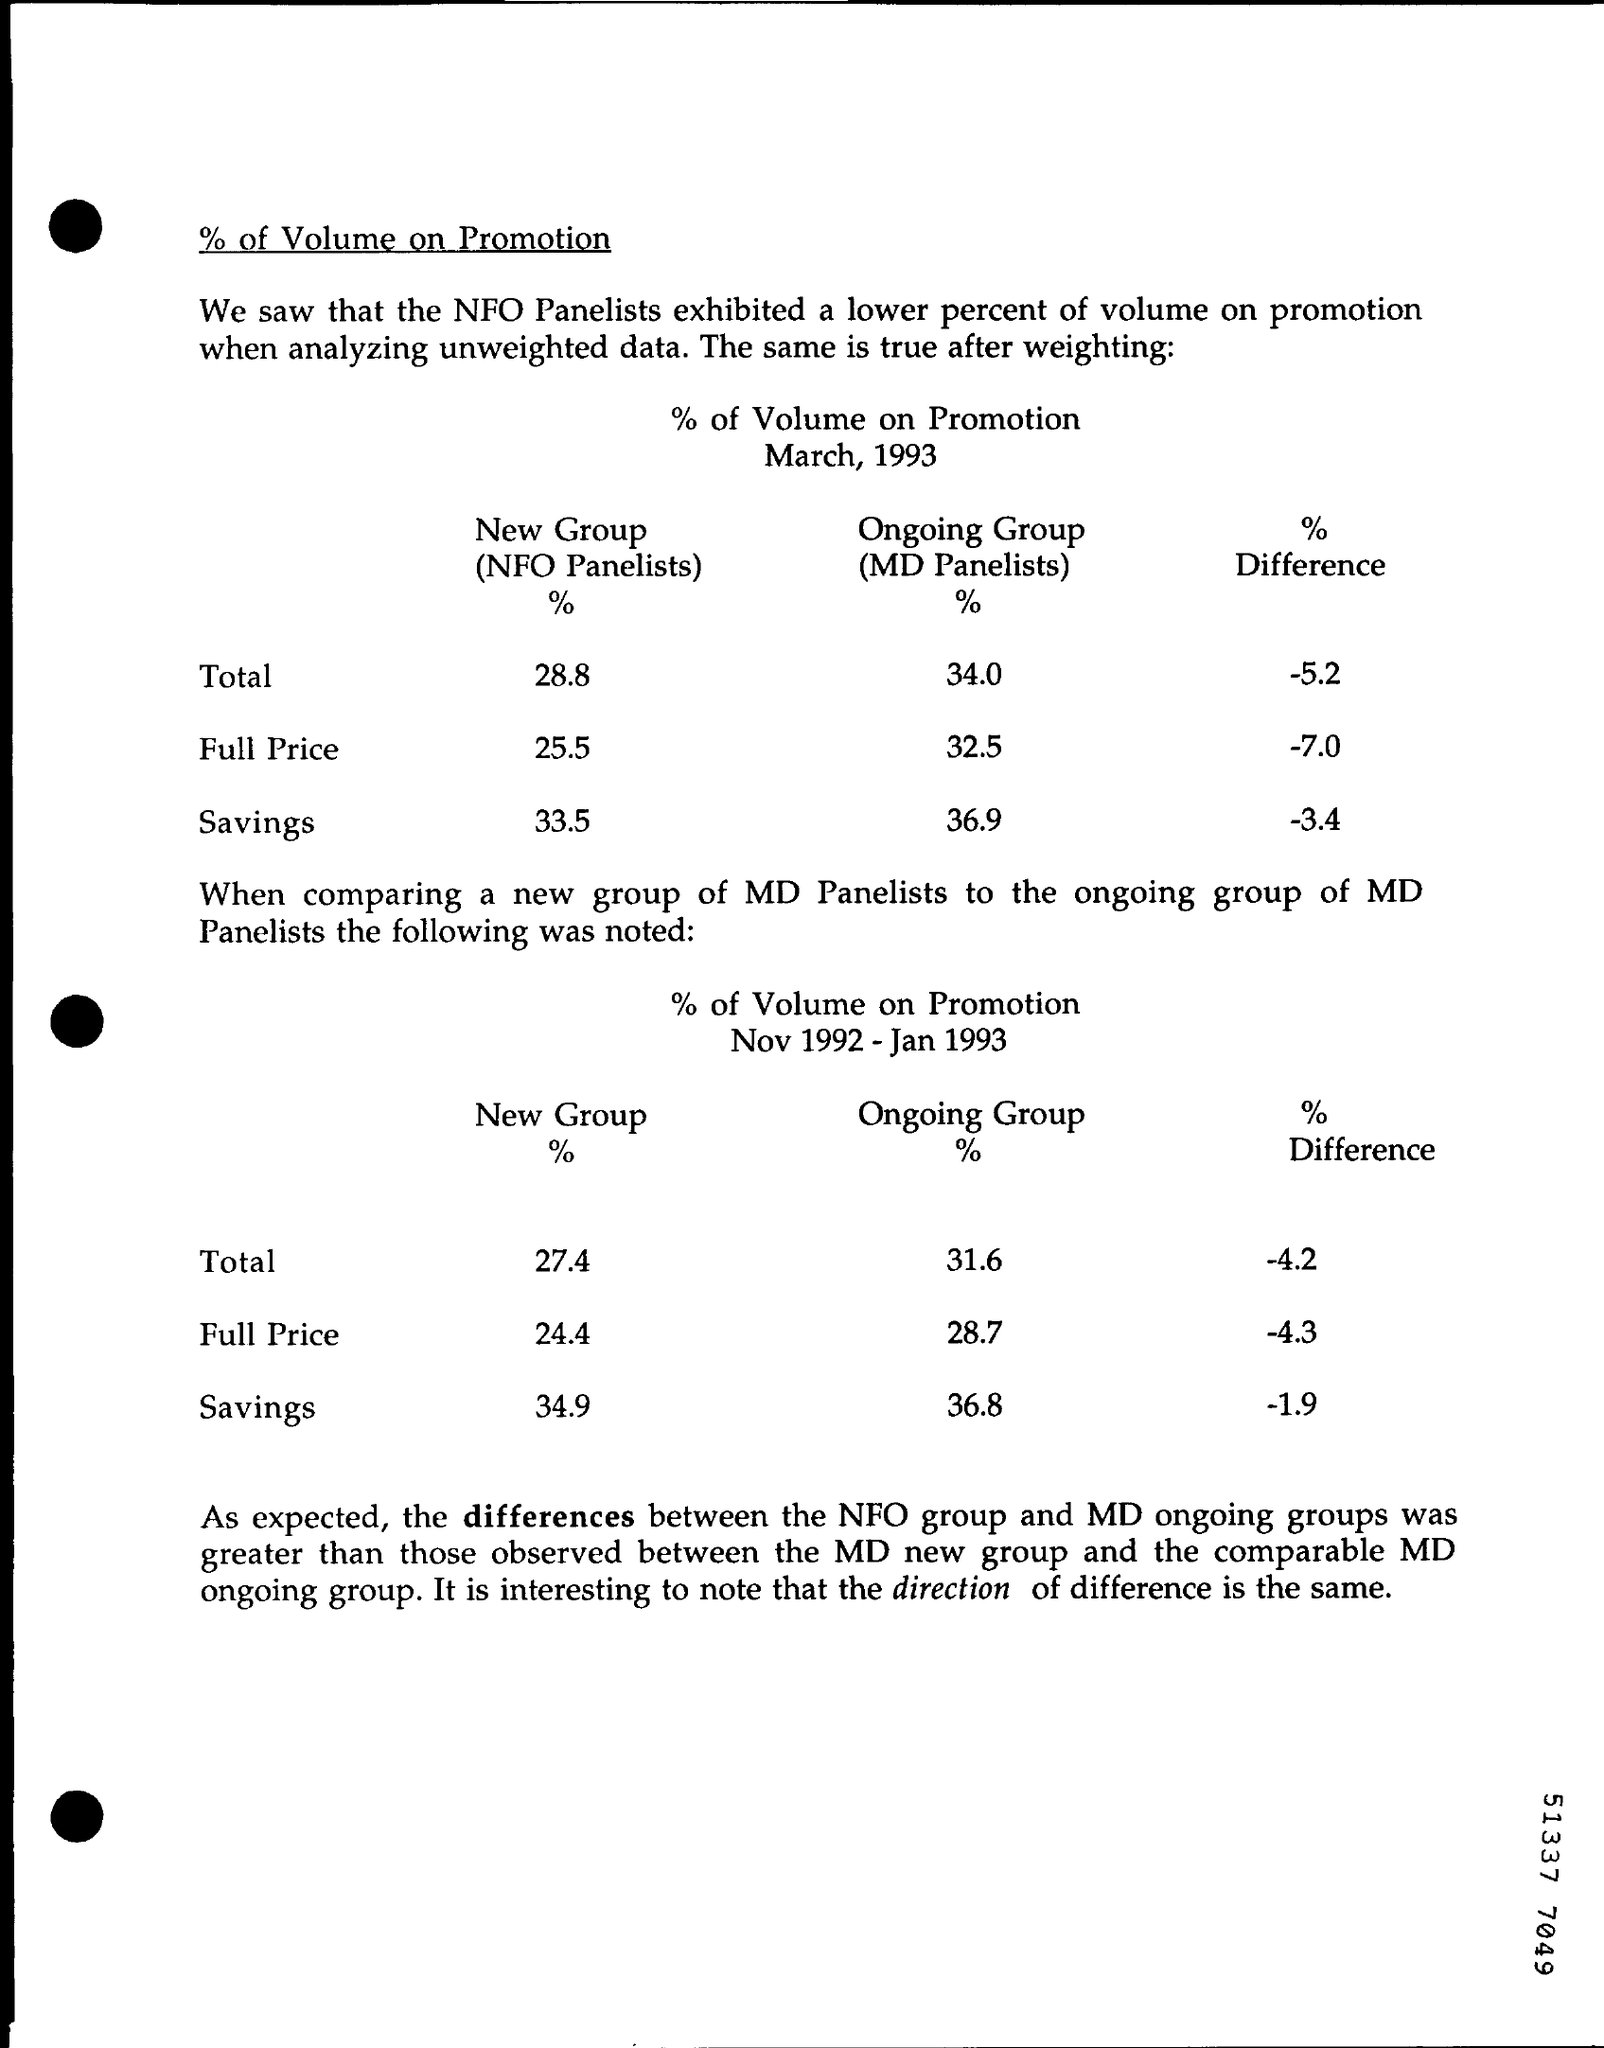What is the Total New Group (NFO Panelists) % for March, 1993?
Provide a short and direct response. 28.8. What is the Total Ongoing Group (MD Panelists) % for March, 1993?
Your response must be concise. 34.0. What is the Total % difference for March, 1993?
Your response must be concise. -5.2. What is the Full Price New Group (NFO Panelists)% For March, 1993?
Provide a short and direct response. 25.5. What is the Full Price % Differencefor March, 1993?
Your response must be concise. -7. What is the Savings New Group (NFO Panelists)% For March, 1993?
Offer a terse response. 33.5. What is the Savings for Ongoing Group (MD Panelists) % for March, 1993?
Offer a terse response. 36.9. What is the Savings % Difference for March, 1993?
Keep it short and to the point. -3.4. 